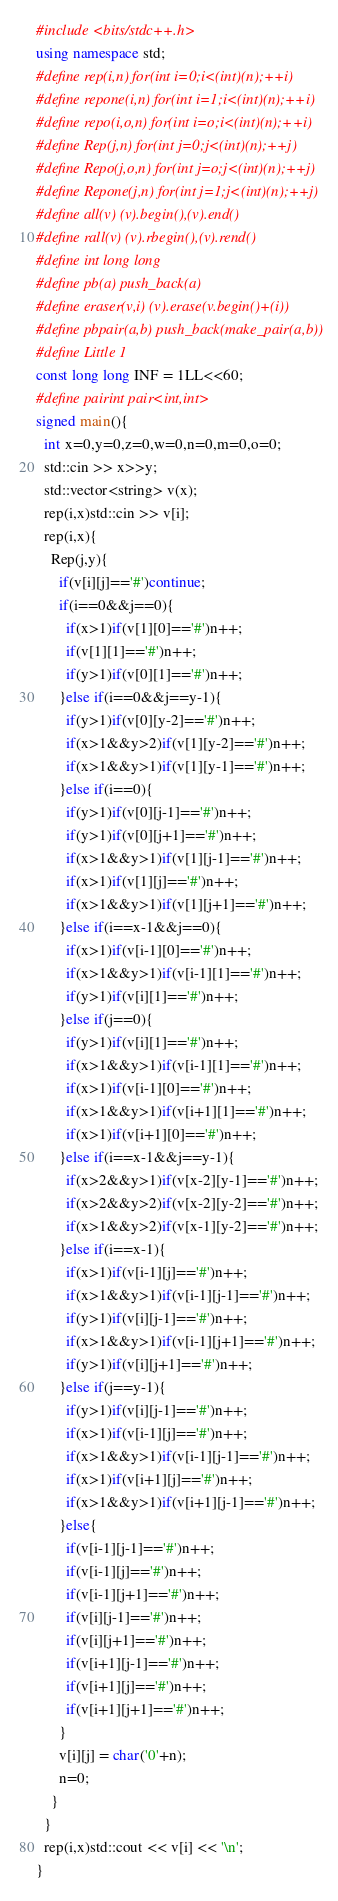<code> <loc_0><loc_0><loc_500><loc_500><_C++_>#include <bits/stdc++.h>
using namespace std;
#define rep(i,n) for(int i=0;i<(int)(n);++i)
#define repone(i,n) for(int i=1;i<(int)(n);++i)
#define repo(i,o,n) for(int i=o;i<(int)(n);++i)
#define Rep(j,n) for(int j=0;j<(int)(n);++j)
#define Repo(j,o,n) for(int j=o;j<(int)(n);++j)
#define Repone(j,n) for(int j=1;j<(int)(n);++j)
#define all(v) (v).begin(),(v).end()
#define rall(v) (v).rbegin(),(v).rend()
#define int long long
#define pb(a) push_back(a)
#define eraser(v,i) (v).erase(v.begin()+(i))
#define pbpair(a,b) push_back(make_pair(a,b))
#define Little 1
const long long INF = 1LL<<60;
#define pairint pair<int,int>
signed main(){
  int x=0,y=0,z=0,w=0,n=0,m=0,o=0;
  std::cin >> x>>y;
  std::vector<string> v(x);
  rep(i,x)std::cin >> v[i];
  rep(i,x){
    Rep(j,y){
      if(v[i][j]=='#')continue;
      if(i==0&&j==0){
        if(x>1)if(v[1][0]=='#')n++;
        if(v[1][1]=='#')n++;
        if(y>1)if(v[0][1]=='#')n++;
      }else if(i==0&&j==y-1){
        if(y>1)if(v[0][y-2]=='#')n++;
        if(x>1&&y>2)if(v[1][y-2]=='#')n++;
        if(x>1&&y>1)if(v[1][y-1]=='#')n++;
      }else if(i==0){
        if(y>1)if(v[0][j-1]=='#')n++;
        if(y>1)if(v[0][j+1]=='#')n++;
        if(x>1&&y>1)if(v[1][j-1]=='#')n++;
        if(x>1)if(v[1][j]=='#')n++;
        if(x>1&&y>1)if(v[1][j+1]=='#')n++;
      }else if(i==x-1&&j==0){
        if(x>1)if(v[i-1][0]=='#')n++;
        if(x>1&&y>1)if(v[i-1][1]=='#')n++;
        if(y>1)if(v[i][1]=='#')n++;
      }else if(j==0){
        if(y>1)if(v[i][1]=='#')n++;
        if(x>1&&y>1)if(v[i-1][1]=='#')n++;
        if(x>1)if(v[i-1][0]=='#')n++;
        if(x>1&&y>1)if(v[i+1][1]=='#')n++;
        if(x>1)if(v[i+1][0]=='#')n++;
      }else if(i==x-1&&j==y-1){
        if(x>2&&y>1)if(v[x-2][y-1]=='#')n++;
        if(x>2&&y>2)if(v[x-2][y-2]=='#')n++;
        if(x>1&&y>2)if(v[x-1][y-2]=='#')n++;
      }else if(i==x-1){
        if(x>1)if(v[i-1][j]=='#')n++;
        if(x>1&&y>1)if(v[i-1][j-1]=='#')n++;
        if(y>1)if(v[i][j-1]=='#')n++;
        if(x>1&&y>1)if(v[i-1][j+1]=='#')n++;
        if(y>1)if(v[i][j+1]=='#')n++;
      }else if(j==y-1){
        if(y>1)if(v[i][j-1]=='#')n++;
        if(x>1)if(v[i-1][j]=='#')n++;
        if(x>1&&y>1)if(v[i-1][j-1]=='#')n++;
        if(x>1)if(v[i+1][j]=='#')n++;
        if(x>1&&y>1)if(v[i+1][j-1]=='#')n++;
      }else{
        if(v[i-1][j-1]=='#')n++;
        if(v[i-1][j]=='#')n++;
        if(v[i-1][j+1]=='#')n++;
        if(v[i][j-1]=='#')n++;
        if(v[i][j+1]=='#')n++;
        if(v[i+1][j-1]=='#')n++;
        if(v[i+1][j]=='#')n++;
        if(v[i+1][j+1]=='#')n++;
      }
      v[i][j] = char('0'+n);
      n=0;
    }
  }
  rep(i,x)std::cout << v[i] << '\n';
}
</code> 